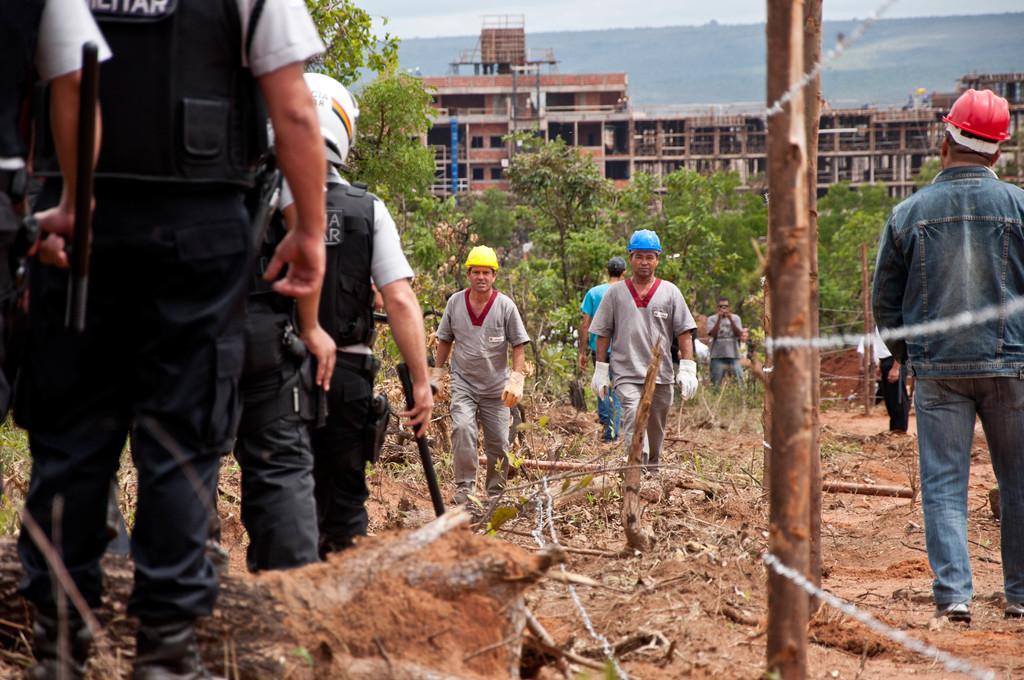Could you give a brief overview of what you see in this image? In this image we can see a few people on the ground, among them, some are holding the objects, there are some buildings, trees and mountains, also we can see the sky. 